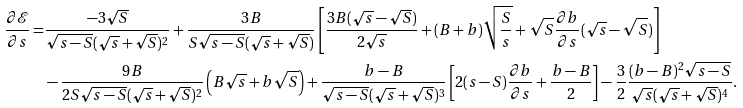Convert formula to latex. <formula><loc_0><loc_0><loc_500><loc_500>\frac { \partial \mathcal { E } } { \partial s } = & \frac { - 3 \sqrt { S } } { \sqrt { s - S } ( \sqrt { s } + \sqrt { S } ) ^ { 2 } } + \frac { 3 B } { S \sqrt { s - S } ( \sqrt { s } + \sqrt { S } ) } \left [ \frac { 3 B ( \sqrt { s } - \sqrt { S } ) } { 2 \sqrt { s } } + ( B + b ) \sqrt { \frac { S } { s } } + \sqrt { S } \frac { \partial b } { \partial s } ( \sqrt { s } - \sqrt { S } ) \right ] \\ & - \frac { 9 B } { 2 S \sqrt { s - S } ( \sqrt { s } + \sqrt { S } ) ^ { 2 } } \left ( B \sqrt { s } + b \sqrt { S } \right ) + \frac { b - B } { \sqrt { s - S } ( \sqrt { s } + \sqrt { S } ) ^ { 3 } } \left [ 2 ( s - S ) \frac { \partial b } { \partial s } + \frac { b - B } { 2 } \right ] - \frac { 3 } { 2 } \frac { ( b - B ) ^ { 2 } \sqrt { s - S } } { \sqrt { s } ( \sqrt { s } + \sqrt { S } ) ^ { 4 } } .</formula> 